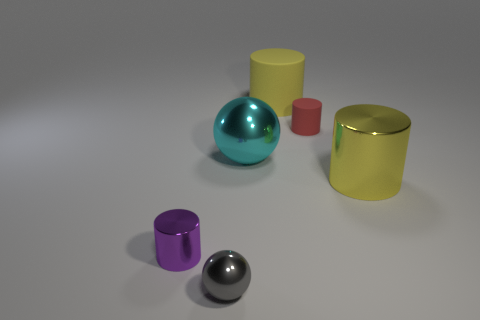Subtract all large matte cylinders. How many cylinders are left? 3 Add 4 spheres. How many objects exist? 10 Subtract all red cylinders. How many cylinders are left? 3 Subtract all cylinders. How many objects are left? 2 Subtract 2 cylinders. How many cylinders are left? 2 Subtract all large matte cylinders. Subtract all tiny rubber things. How many objects are left? 4 Add 6 tiny objects. How many tiny objects are left? 9 Add 4 yellow objects. How many yellow objects exist? 6 Subtract 1 cyan balls. How many objects are left? 5 Subtract all blue spheres. Subtract all yellow cubes. How many spheres are left? 2 